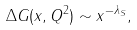Convert formula to latex. <formula><loc_0><loc_0><loc_500><loc_500>\Delta G ( x , Q ^ { 2 } ) \sim x ^ { - \lambda _ { S } } ,</formula> 